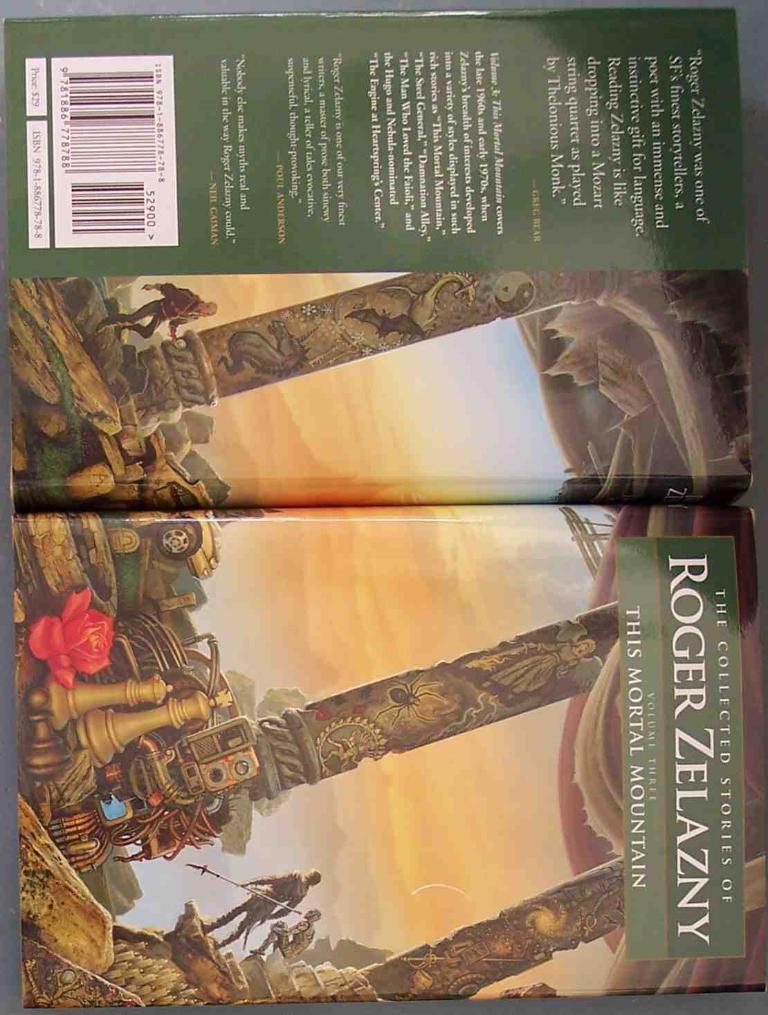Who is this story told by?
Ensure brevity in your answer.  Roger zelazny. What is the title?
Give a very brief answer. This mortal mountain. 